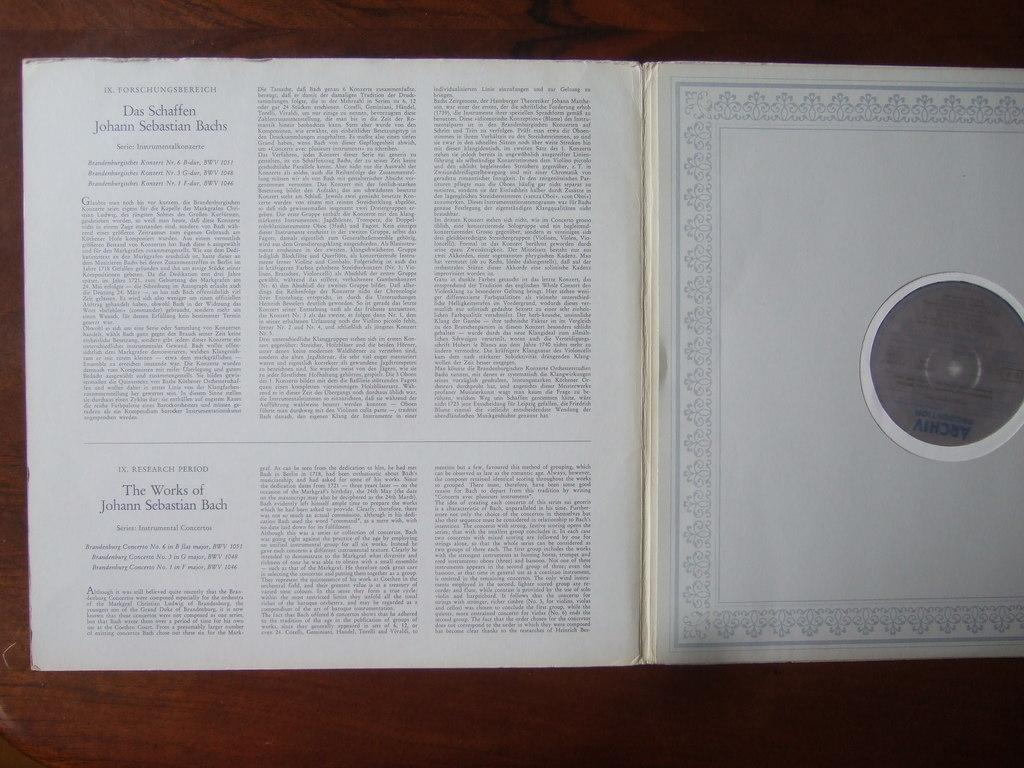<image>
Share a concise interpretation of the image provided. Two translations of The Works of Johann Sebastian Bach. 